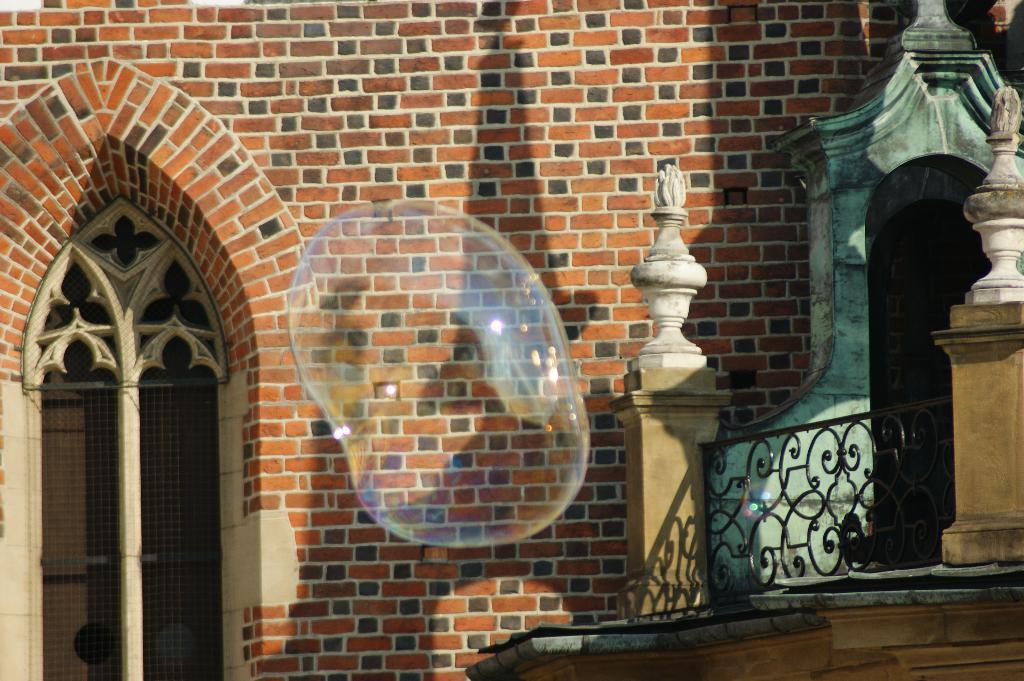What can be seen floating in the picture? There is a bubble in the picture. What type of structure is present in the picture? There is a brick wall in the picture, which has a window on it. What type of barrier is visible in the picture? There is a fence in the picture. What can be found in the right corner of the picture? There are other objects in the right corner of the picture. How many children are playing with the notebook in the picture? There is no notebook or children present in the picture. What type of girls can be seen interacting with the bubble in the picture? There are no girls present in the picture; it only features a bubble, a brick wall, a window, a fence, and other objects in the right corner. 